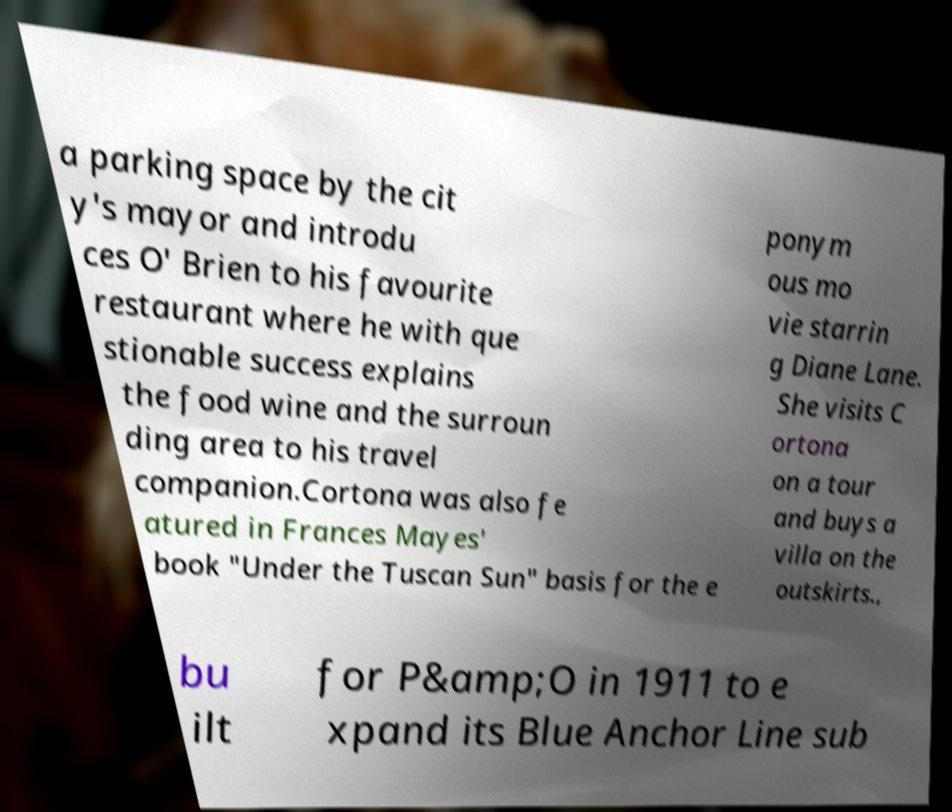Can you accurately transcribe the text from the provided image for me? a parking space by the cit y's mayor and introdu ces O' Brien to his favourite restaurant where he with que stionable success explains the food wine and the surroun ding area to his travel companion.Cortona was also fe atured in Frances Mayes' book "Under the Tuscan Sun" basis for the e ponym ous mo vie starrin g Diane Lane. She visits C ortona on a tour and buys a villa on the outskirts., bu ilt for P&amp;O in 1911 to e xpand its Blue Anchor Line sub 